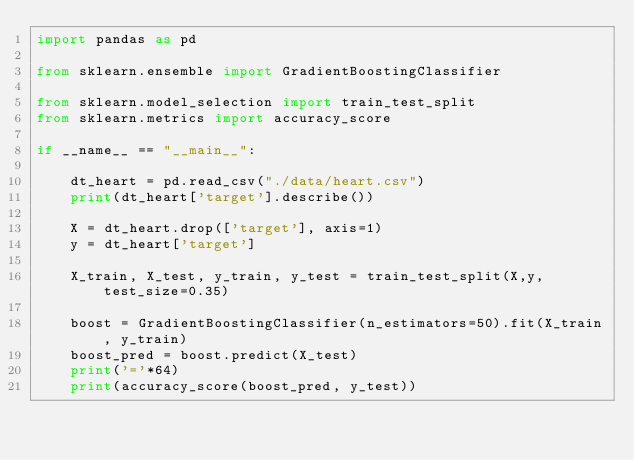<code> <loc_0><loc_0><loc_500><loc_500><_Python_>import pandas as pd

from sklearn.ensemble import GradientBoostingClassifier

from sklearn.model_selection import train_test_split
from sklearn.metrics import accuracy_score

if __name__ == "__main__":

    dt_heart = pd.read_csv("./data/heart.csv")
    print(dt_heart['target'].describe())

    X = dt_heart.drop(['target'], axis=1)
    y = dt_heart['target']

    X_train, X_test, y_train, y_test = train_test_split(X,y,test_size=0.35)

    boost = GradientBoostingClassifier(n_estimators=50).fit(X_train, y_train)
    boost_pred = boost.predict(X_test)
    print('='*64)
    print(accuracy_score(boost_pred, y_test))


</code> 